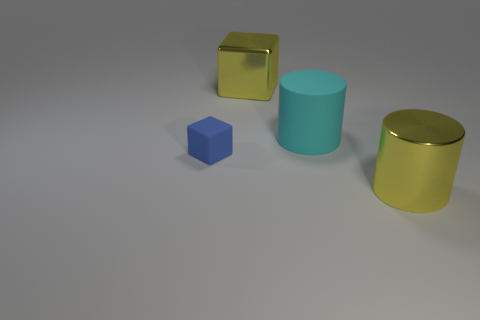What materials appear to be represented by the objects in the image? The objects in the image appear to have different textures, suggesting various materials. The small blue cube seems matte, indicating a non-reflective surface, while the two larger cylinders appear shiny and might represent metal or plastic due to their reflective surfaces. The golden cube also has a reflective surface, consistent with a polished metallic finish. 